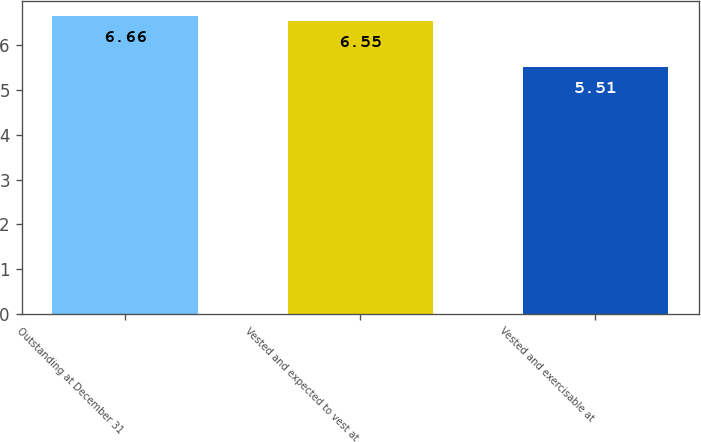Convert chart. <chart><loc_0><loc_0><loc_500><loc_500><bar_chart><fcel>Outstanding at December 31<fcel>Vested and expected to vest at<fcel>Vested and exercisable at<nl><fcel>6.66<fcel>6.55<fcel>5.51<nl></chart> 